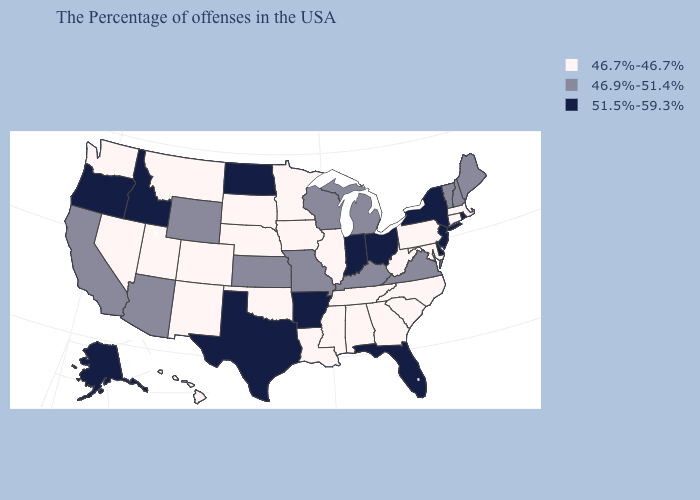Which states have the highest value in the USA?
Concise answer only. Rhode Island, New York, New Jersey, Delaware, Ohio, Florida, Indiana, Arkansas, Texas, North Dakota, Idaho, Oregon, Alaska. Which states hav the highest value in the MidWest?
Be succinct. Ohio, Indiana, North Dakota. What is the highest value in the USA?
Give a very brief answer. 51.5%-59.3%. Is the legend a continuous bar?
Answer briefly. No. Name the states that have a value in the range 51.5%-59.3%?
Be succinct. Rhode Island, New York, New Jersey, Delaware, Ohio, Florida, Indiana, Arkansas, Texas, North Dakota, Idaho, Oregon, Alaska. Which states hav the highest value in the Northeast?
Be succinct. Rhode Island, New York, New Jersey. Name the states that have a value in the range 51.5%-59.3%?
Concise answer only. Rhode Island, New York, New Jersey, Delaware, Ohio, Florida, Indiana, Arkansas, Texas, North Dakota, Idaho, Oregon, Alaska. Name the states that have a value in the range 46.7%-46.7%?
Write a very short answer. Massachusetts, Connecticut, Maryland, Pennsylvania, North Carolina, South Carolina, West Virginia, Georgia, Alabama, Tennessee, Illinois, Mississippi, Louisiana, Minnesota, Iowa, Nebraska, Oklahoma, South Dakota, Colorado, New Mexico, Utah, Montana, Nevada, Washington, Hawaii. What is the lowest value in states that border Indiana?
Write a very short answer. 46.7%-46.7%. What is the lowest value in states that border Massachusetts?
Keep it brief. 46.7%-46.7%. Does Rhode Island have the highest value in the Northeast?
Keep it brief. Yes. What is the value of Alabama?
Concise answer only. 46.7%-46.7%. Among the states that border New Hampshire , which have the highest value?
Concise answer only. Maine, Vermont. Which states have the highest value in the USA?
Be succinct. Rhode Island, New York, New Jersey, Delaware, Ohio, Florida, Indiana, Arkansas, Texas, North Dakota, Idaho, Oregon, Alaska. 